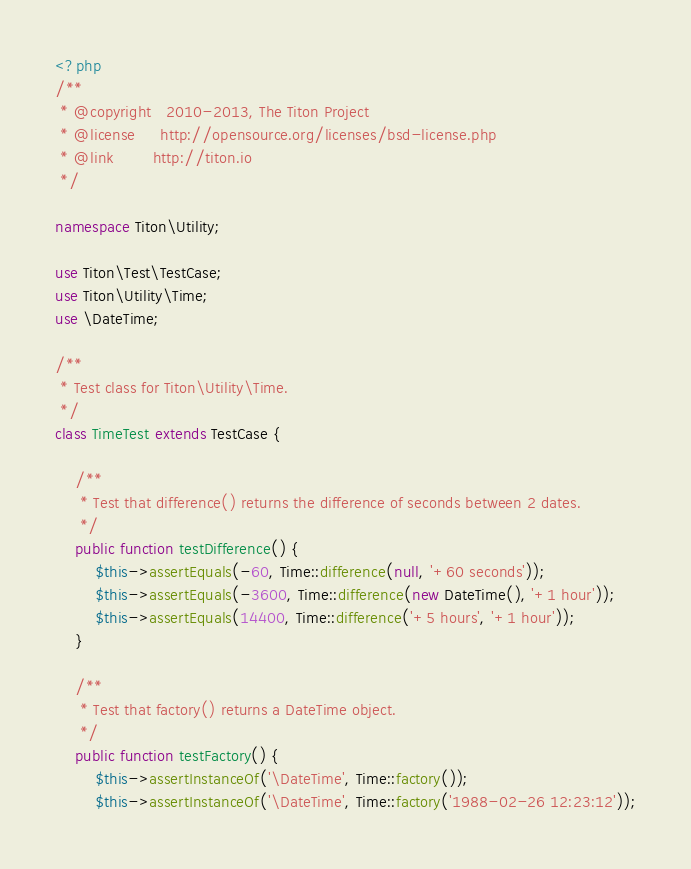<code> <loc_0><loc_0><loc_500><loc_500><_PHP_><?php
/**
 * @copyright   2010-2013, The Titon Project
 * @license     http://opensource.org/licenses/bsd-license.php
 * @link        http://titon.io
 */

namespace Titon\Utility;

use Titon\Test\TestCase;
use Titon\Utility\Time;
use \DateTime;

/**
 * Test class for Titon\Utility\Time.
 */
class TimeTest extends TestCase {

    /**
     * Test that difference() returns the difference of seconds between 2 dates.
     */
    public function testDifference() {
        $this->assertEquals(-60, Time::difference(null, '+60 seconds'));
        $this->assertEquals(-3600, Time::difference(new DateTime(), '+1 hour'));
        $this->assertEquals(14400, Time::difference('+5 hours', '+1 hour'));
    }

    /**
     * Test that factory() returns a DateTime object.
     */
    public function testFactory() {
        $this->assertInstanceOf('\DateTime', Time::factory());
        $this->assertInstanceOf('\DateTime', Time::factory('1988-02-26 12:23:12'));</code> 